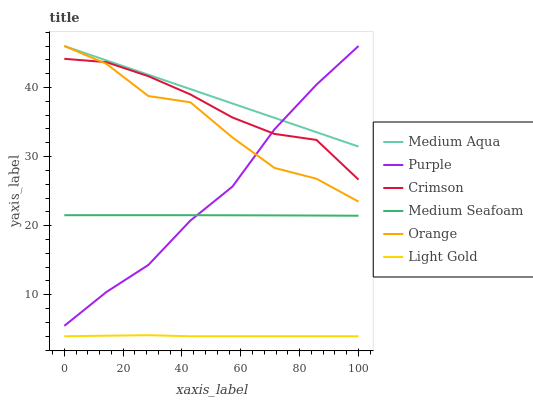Does Light Gold have the minimum area under the curve?
Answer yes or no. Yes. Does Medium Aqua have the maximum area under the curve?
Answer yes or no. Yes. Does Orange have the minimum area under the curve?
Answer yes or no. No. Does Orange have the maximum area under the curve?
Answer yes or no. No. Is Medium Aqua the smoothest?
Answer yes or no. Yes. Is Orange the roughest?
Answer yes or no. Yes. Is Orange the smoothest?
Answer yes or no. No. Is Medium Aqua the roughest?
Answer yes or no. No. Does Light Gold have the lowest value?
Answer yes or no. Yes. Does Orange have the lowest value?
Answer yes or no. No. Does Medium Aqua have the highest value?
Answer yes or no. Yes. Does Crimson have the highest value?
Answer yes or no. No. Is Light Gold less than Crimson?
Answer yes or no. Yes. Is Medium Aqua greater than Crimson?
Answer yes or no. Yes. Does Purple intersect Medium Seafoam?
Answer yes or no. Yes. Is Purple less than Medium Seafoam?
Answer yes or no. No. Is Purple greater than Medium Seafoam?
Answer yes or no. No. Does Light Gold intersect Crimson?
Answer yes or no. No. 